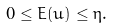Convert formula to latex. <formula><loc_0><loc_0><loc_500><loc_500>0 \leq E ( u ) \leq \eta .</formula> 